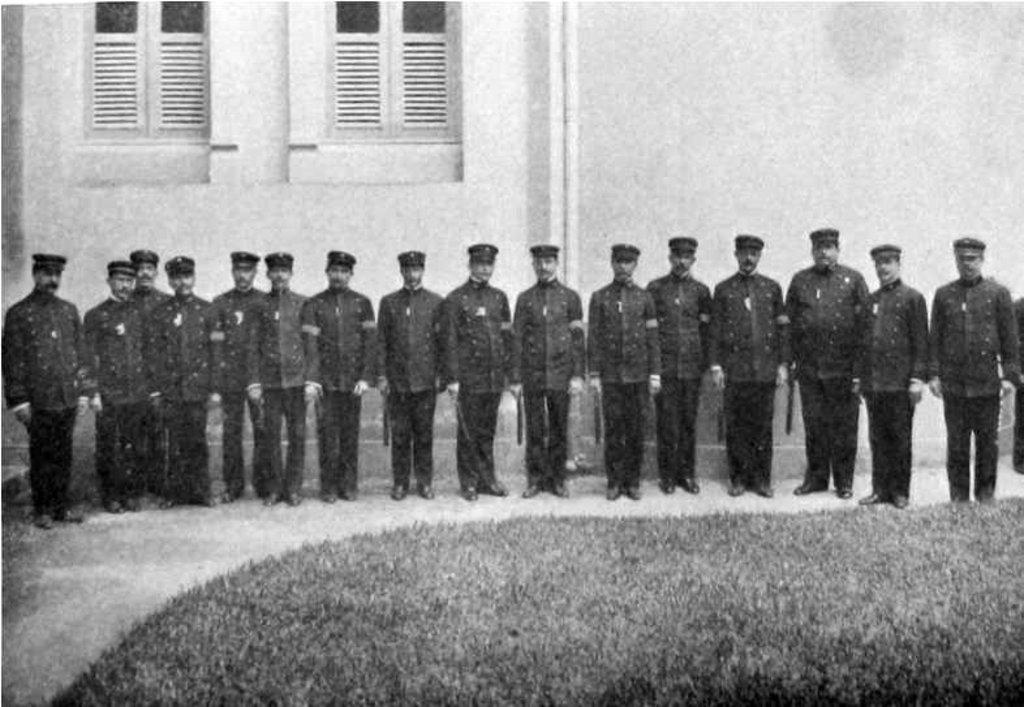What can be seen in the image? There are people standing in the image. What is the surface they are standing on? The people are standing on land with grass. What are the people wearing on their heads? The people are wearing caps. What is visible in the background of the image? There is a wall in the background of the image. What feature does the wall have? The wall has windows. What type of mint plant can be seen growing near the people in the image? There is no mint plant visible in the image. 